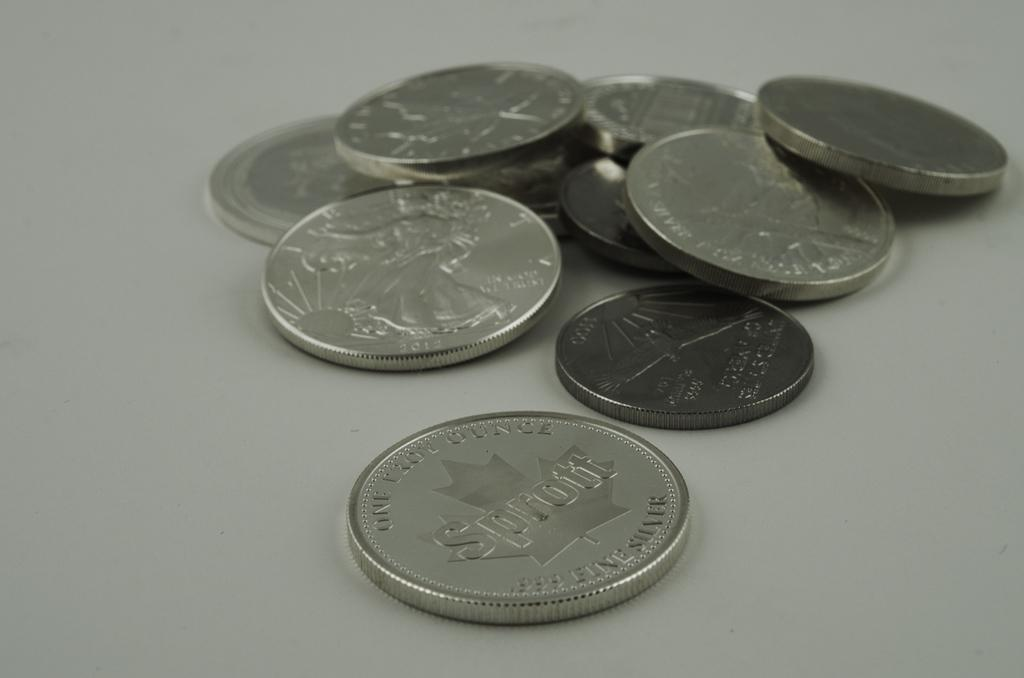<image>
Share a concise interpretation of the image provided. An one troy ounce coin on a table next to a pile of other coins. 